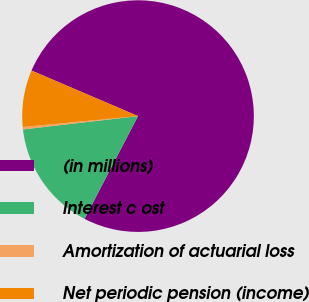Convert chart to OTSL. <chart><loc_0><loc_0><loc_500><loc_500><pie_chart><fcel>(in millions)<fcel>Interest c ost<fcel>Amortization of actuarial loss<fcel>Net periodic pension (income)<nl><fcel>76.22%<fcel>15.52%<fcel>0.34%<fcel>7.93%<nl></chart> 